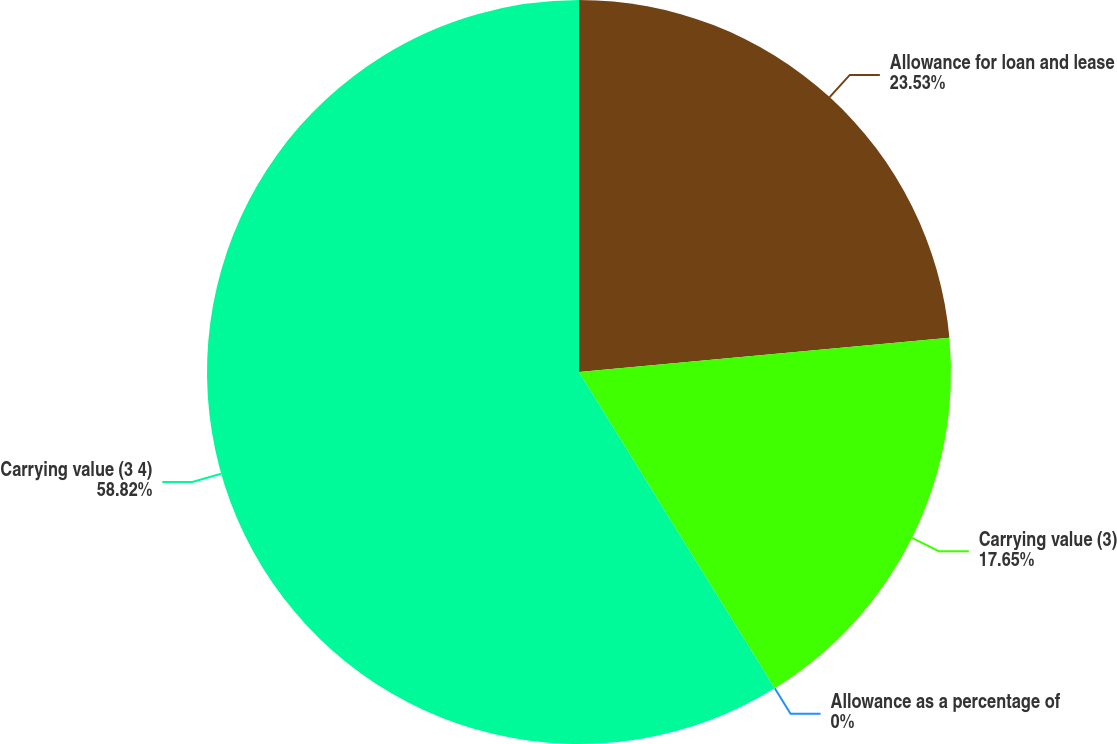<chart> <loc_0><loc_0><loc_500><loc_500><pie_chart><fcel>Allowance for loan and lease<fcel>Carrying value (3)<fcel>Allowance as a percentage of<fcel>Carrying value (3 4)<nl><fcel>23.53%<fcel>17.65%<fcel>0.0%<fcel>58.82%<nl></chart> 